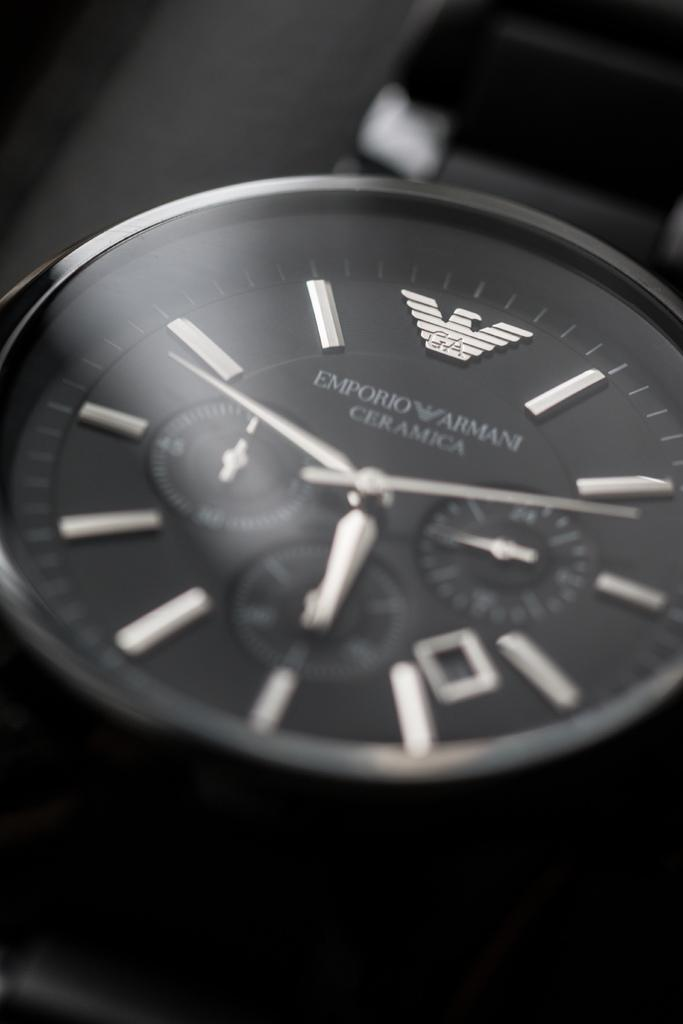Provide a one-sentence caption for the provided image. A close up of an Armani watch shows the time as 5:49. 